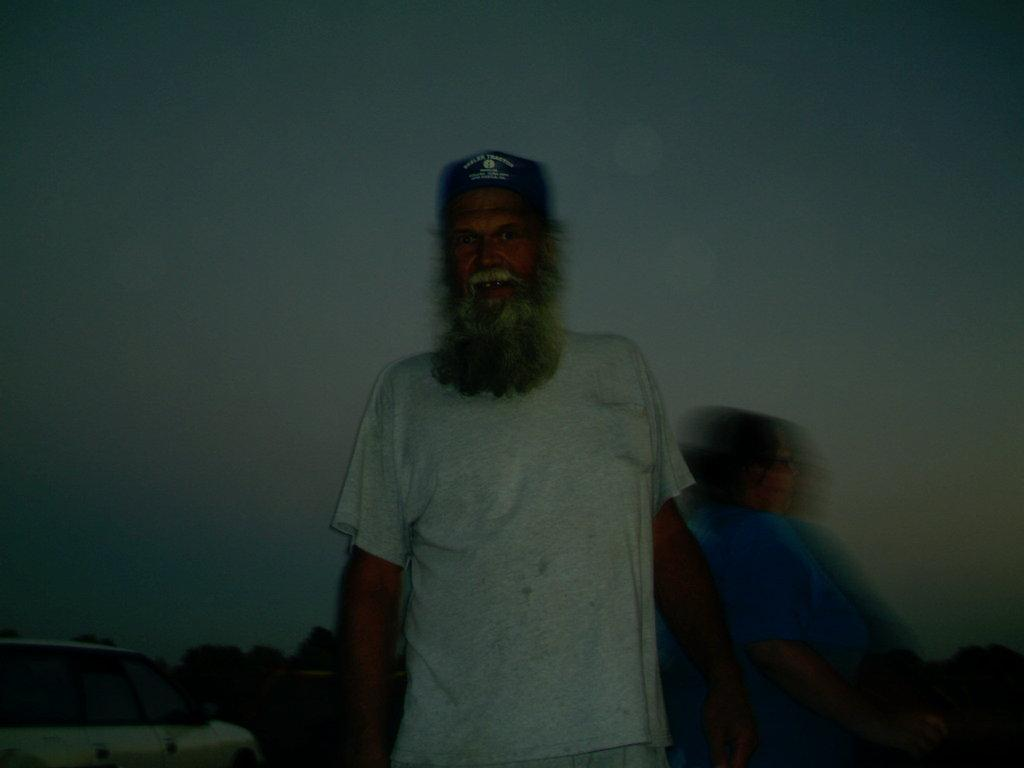What is the main subject of the image? There is a man standing in the image. What can be seen in the background of the image? There is sky, a car, and trees visible in the background of the image. What type of screw can be seen holding the man's dress in the image? There is no screw or dress present in the image; the man is simply standing. How does the man maintain his balance in the image? The image does not show the man in a precarious position, so there is no need for him to maintain his balance. 